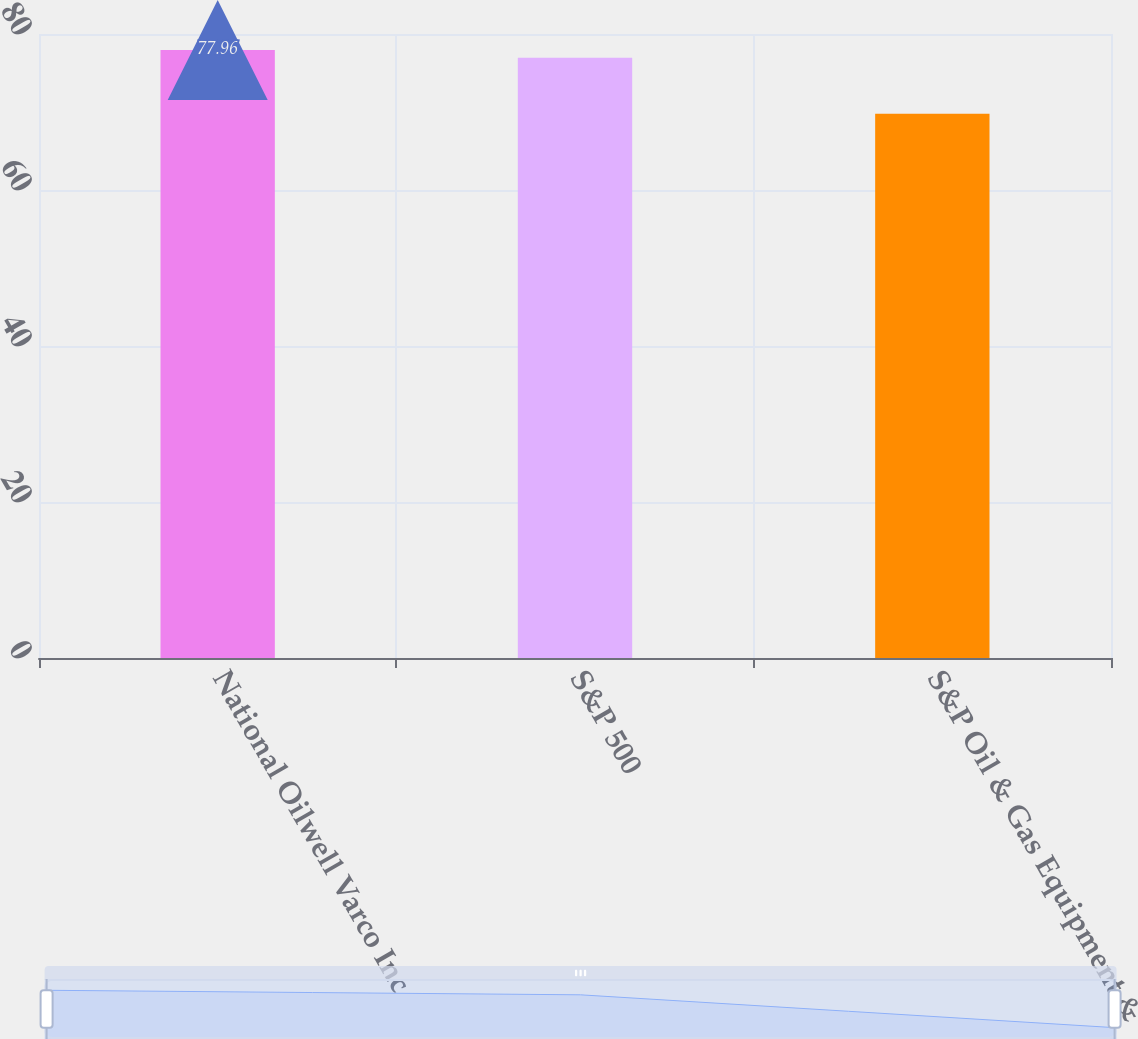<chart> <loc_0><loc_0><loc_500><loc_500><bar_chart><fcel>National Oilwell Varco Inc<fcel>S&P 500<fcel>S&P Oil & Gas Equipment &<nl><fcel>77.96<fcel>76.96<fcel>69.76<nl></chart> 